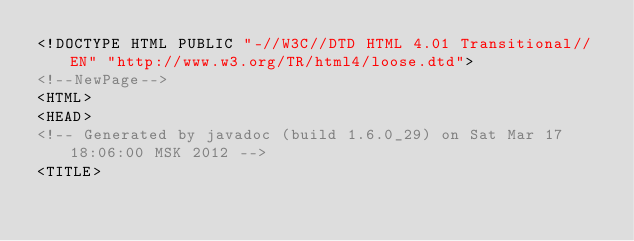Convert code to text. <code><loc_0><loc_0><loc_500><loc_500><_HTML_><!DOCTYPE HTML PUBLIC "-//W3C//DTD HTML 4.01 Transitional//EN" "http://www.w3.org/TR/html4/loose.dtd">
<!--NewPage-->
<HTML>
<HEAD>
<!-- Generated by javadoc (build 1.6.0_29) on Sat Mar 17 18:06:00 MSK 2012 -->
<TITLE></code> 